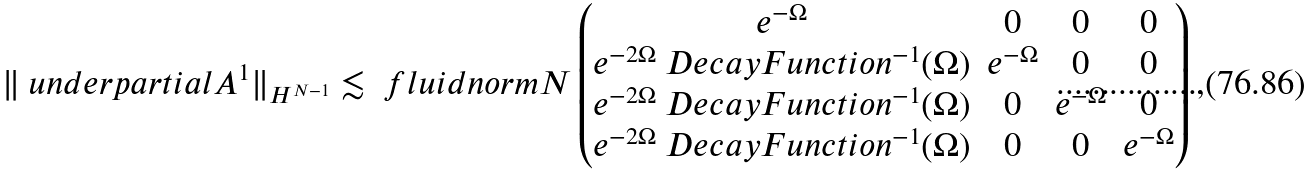Convert formula to latex. <formula><loc_0><loc_0><loc_500><loc_500>\| \ u n d e r p a r t i a l A ^ { 1 } \| _ { H ^ { N - 1 } } & \lesssim \ f l u i d n o r m { N } \begin{pmatrix} e ^ { - \Omega } & 0 & 0 & 0 \\ e ^ { - 2 \Omega } \ D e c a y F u n c t i o n ^ { - 1 } ( \Omega ) & e ^ { - \Omega } & 0 & 0 \\ e ^ { - 2 \Omega } \ D e c a y F u n c t i o n ^ { - 1 } ( \Omega ) & 0 & e ^ { - \Omega } & 0 \\ e ^ { - 2 \Omega } \ D e c a y F u n c t i o n ^ { - 1 } ( \Omega ) & 0 & 0 & e ^ { - \Omega } \\ \end{pmatrix} ,</formula> 